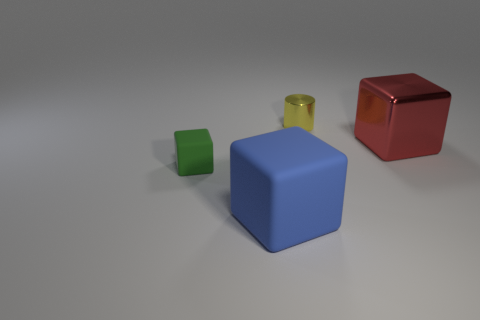Add 2 tiny purple matte objects. How many objects exist? 6 Subtract all cylinders. How many objects are left? 3 Add 3 blue rubber cubes. How many blue rubber cubes exist? 4 Subtract 0 gray blocks. How many objects are left? 4 Subtract all tiny cylinders. Subtract all small green cubes. How many objects are left? 2 Add 1 big red cubes. How many big red cubes are left? 2 